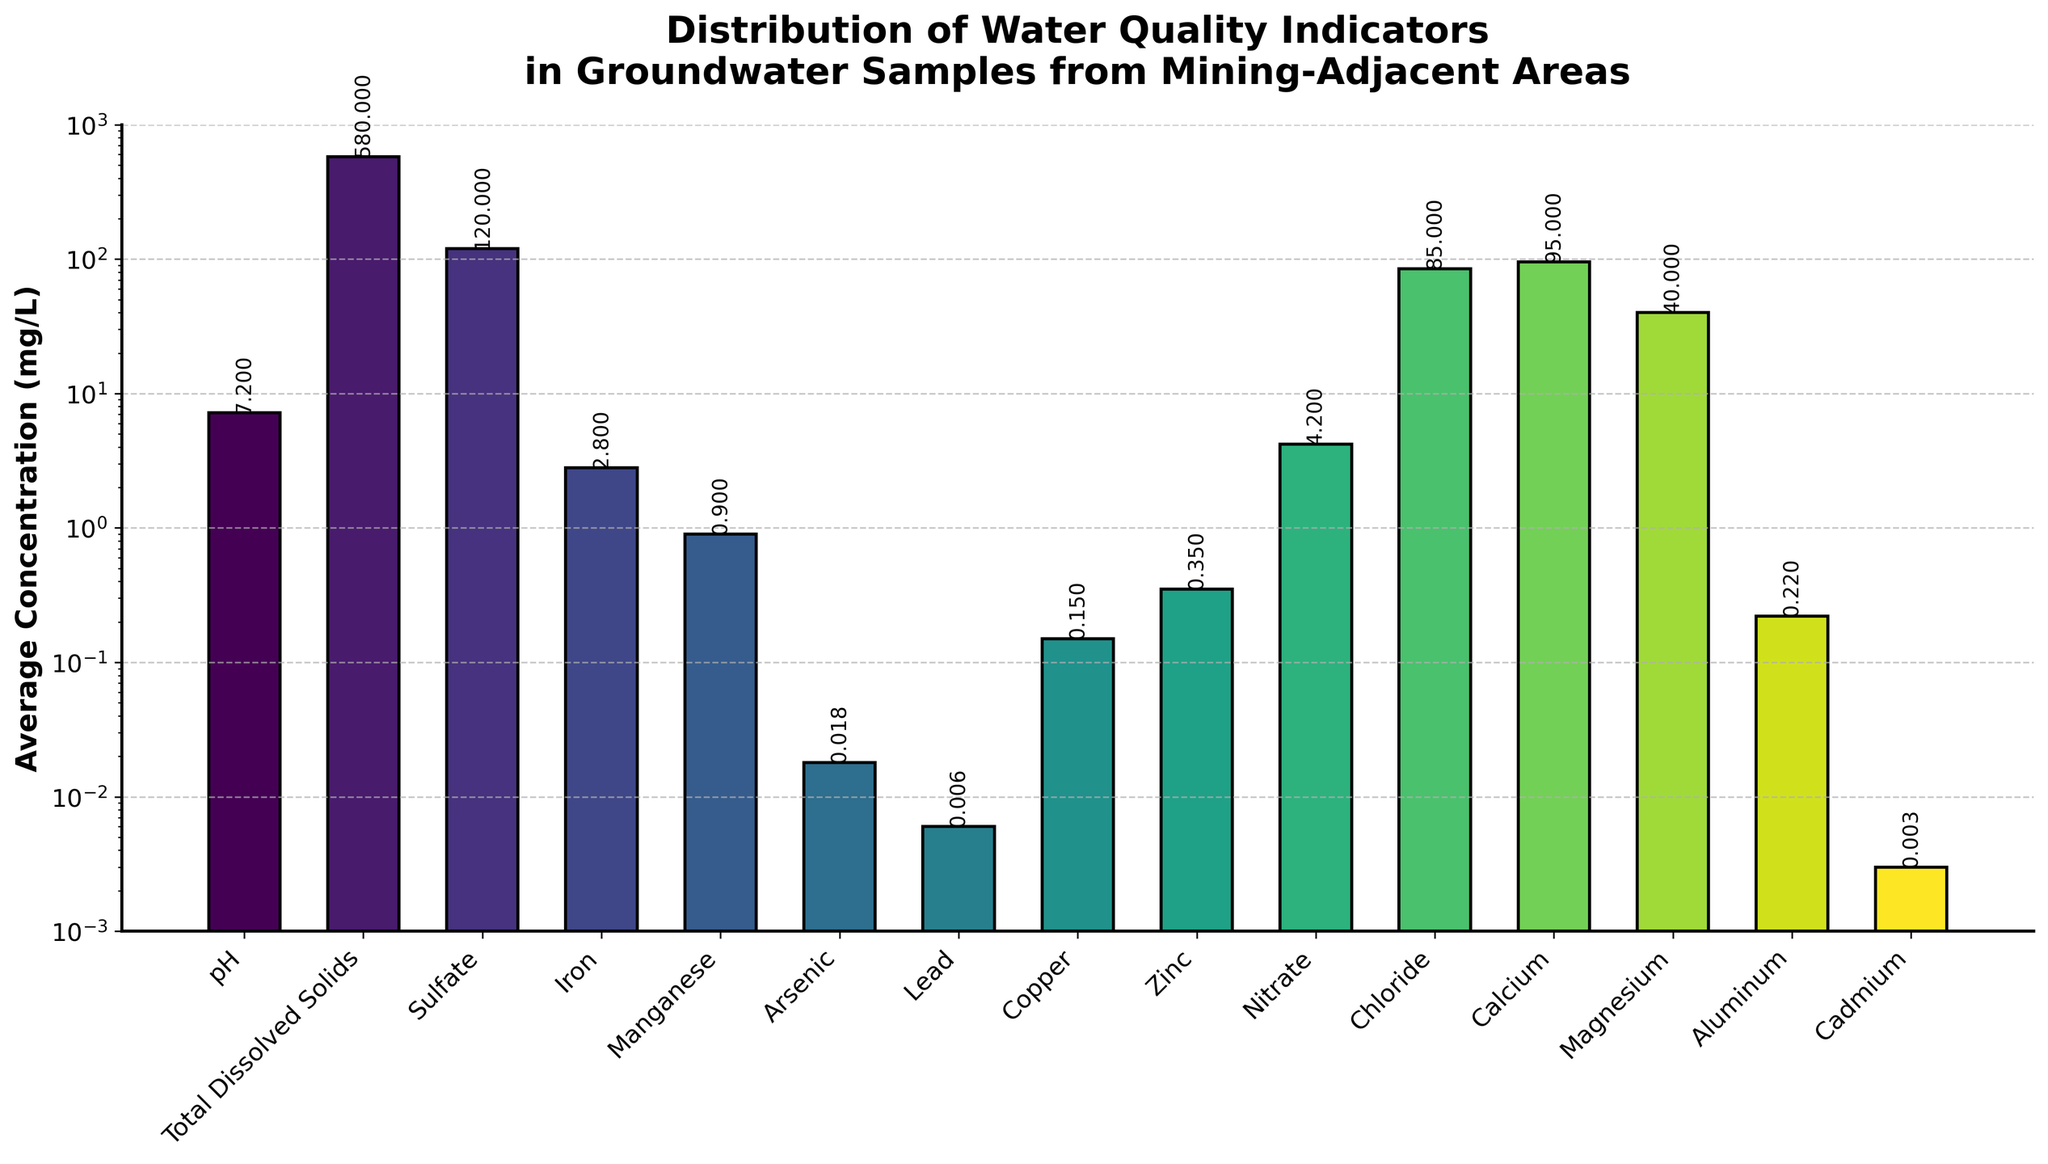What is the average concentration of Magnesium (Mg) compared to Nitrate (NO3)? The height of the Magnesium bar is 40 mg/L, and the height of the Nitrate bar is 4.2 mg/L. Therefore, Magnesium has a considerably higher average concentration than Nitrate.
Answer: Magnesium has a higher concentration Which parameter has the highest average concentration? By visually inspecting the height of all the bars, Total Dissolved Solids (580 mg/L) is the tallest, indicating the highest concentration.
Answer: Total Dissolved Solids Which parameter has the lowest average concentration? Observing the shortest bar with the lowest value, we identify that Cadmium (0.003 mg/L) has the lowest average concentration.
Answer: Cadmium Is the average concentration of Lead (Pb) greater than that of Arsenic (As)? The figure shows that Lead's concentration is 0.006 mg/L, while Arsenic's is 0.018 mg/L. Therefore, Lead's concentration is not greater than Arsenic's.
Answer: No What is the sum of average concentrations of Calcium (Ca) and Magnesium (Mg)? The average concentration of Calcium is 95 mg/L, and Magnesium is 40 mg/L. Summing these values gives 95 + 40 = 135 mg/L.
Answer: 135 mg/L Which has a higher average concentration, Chloride (Cl) or Sulfate (SO4)? From the visual, Chloride's concentration is 85 mg/L, which is, indeed, lower than Sulfate’s concentration of 120 mg/L.
Answer: Sulfate How many parameters have average concentrations below 1 mg/L? Observing the figure's bars under 1 mg/L: Manganese, Arsenic, Lead, Copper, Zinc, Aluminum, and Cadmium. There are 7 such parameters.
Answer: 7 Is the log scale necessary to represent the data effectively? Since the concentrations range from 0.003 mg/L (Cadmium) to 580 mg/L (Total Dissolved Solids), the large variability in data values makes a log scale necessary for better visualization and comparison.
Answer: Yes What is the average concentration of elements (Iron, Manganese, Copper, Zinc) combined? Combination of concentrations: Iron (2.8) + Manganese (0.9) + Copper (0.15) + Zinc (0.35) = 4.2 mg/L. Average = 4.2 / 4 = 1.05 mg/L.
Answer: 1.05 mg/L What is the average concentration of Total Dissolved Solids compared to the sum of all metal concentrations (Iron, Manganese, Arsenic, Lead, Copper, Zinc, Aluminum, Cadmium)? Total metal concentrations sum: 2.8 + 0.9 + 0.018 + 0.006 + 0.15 + 0.35 + 0.22 + 0.003 = 4.447 mg/L. Hence, Total Dissolved Solids (580 mg/L) significantly exceeds the sum of metal concentrations.
Answer: Total Dissolved Solids is higher 